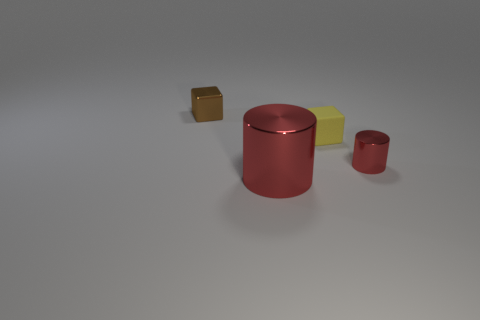Is the color of the shiny object that is right of the tiny yellow object the same as the big shiny object?
Give a very brief answer. Yes. There is a brown metallic thing; what number of cubes are in front of it?
Ensure brevity in your answer.  1. Is the small red cylinder made of the same material as the block that is behind the small matte object?
Provide a succinct answer. Yes. There is a block that is made of the same material as the small cylinder; what size is it?
Your response must be concise. Small. Are there more cylinders in front of the small cylinder than small metallic cylinders that are behind the small brown block?
Your answer should be very brief. Yes. Is there a tiny red object that has the same shape as the large red metal thing?
Your response must be concise. Yes. Does the thing right of the matte object have the same size as the tiny yellow object?
Offer a very short reply. Yes. Are any tiny red things visible?
Ensure brevity in your answer.  Yes. What number of objects are tiny blocks on the right side of the tiny shiny cube or matte things?
Keep it short and to the point. 1. There is a tiny metallic cylinder; does it have the same color as the large cylinder that is to the left of the tiny yellow rubber thing?
Offer a very short reply. Yes. 